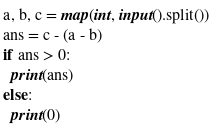<code> <loc_0><loc_0><loc_500><loc_500><_Python_>a, b, c = map(int, input().split())
ans = c - (a - b)
if ans > 0:
  print(ans)
else:
  print(0)</code> 